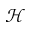<formula> <loc_0><loc_0><loc_500><loc_500>\mathcal { H }</formula> 